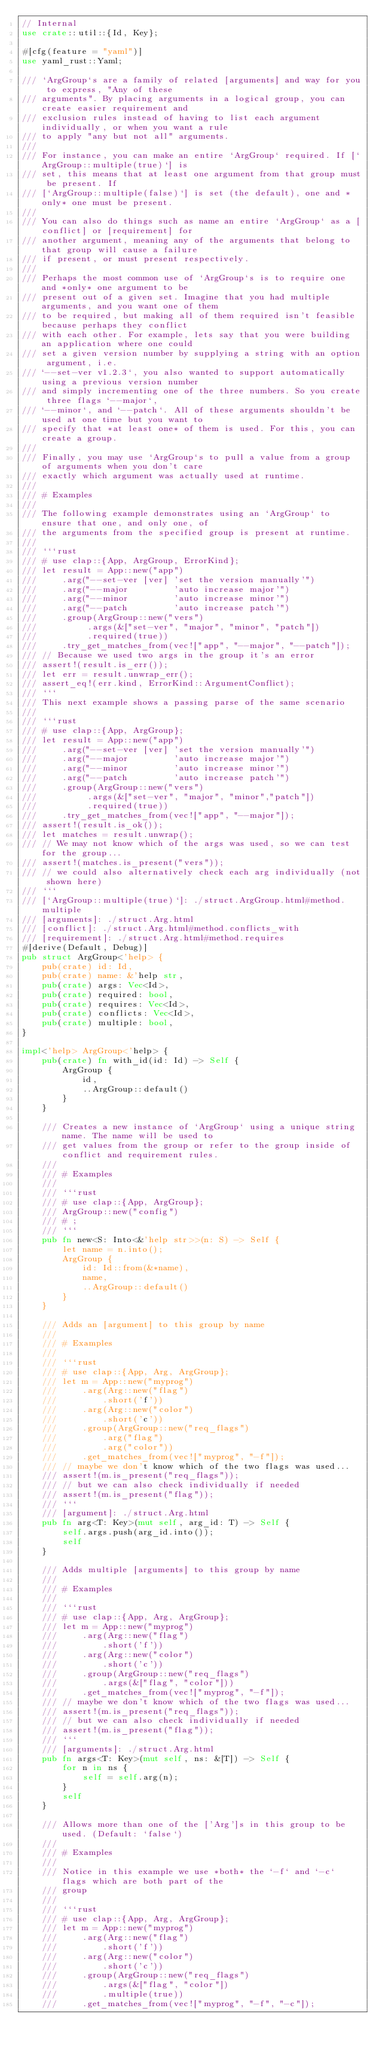Convert code to text. <code><loc_0><loc_0><loc_500><loc_500><_Rust_>// Internal
use crate::util::{Id, Key};

#[cfg(feature = "yaml")]
use yaml_rust::Yaml;

/// `ArgGroup`s are a family of related [arguments] and way for you to express, "Any of these
/// arguments". By placing arguments in a logical group, you can create easier requirement and
/// exclusion rules instead of having to list each argument individually, or when you want a rule
/// to apply "any but not all" arguments.
///
/// For instance, you can make an entire `ArgGroup` required. If [`ArgGroup::multiple(true)`] is
/// set, this means that at least one argument from that group must be present. If
/// [`ArgGroup::multiple(false)`] is set (the default), one and *only* one must be present.
///
/// You can also do things such as name an entire `ArgGroup` as a [conflict] or [requirement] for
/// another argument, meaning any of the arguments that belong to that group will cause a failure
/// if present, or must present respectively.
///
/// Perhaps the most common use of `ArgGroup`s is to require one and *only* one argument to be
/// present out of a given set. Imagine that you had multiple arguments, and you want one of them
/// to be required, but making all of them required isn't feasible because perhaps they conflict
/// with each other. For example, lets say that you were building an application where one could
/// set a given version number by supplying a string with an option argument, i.e.
/// `--set-ver v1.2.3`, you also wanted to support automatically using a previous version number
/// and simply incrementing one of the three numbers. So you create three flags `--major`,
/// `--minor`, and `--patch`. All of these arguments shouldn't be used at one time but you want to
/// specify that *at least one* of them is used. For this, you can create a group.
///
/// Finally, you may use `ArgGroup`s to pull a value from a group of arguments when you don't care
/// exactly which argument was actually used at runtime.
///
/// # Examples
///
/// The following example demonstrates using an `ArgGroup` to ensure that one, and only one, of
/// the arguments from the specified group is present at runtime.
///
/// ```rust
/// # use clap::{App, ArgGroup, ErrorKind};
/// let result = App::new("app")
///     .arg("--set-ver [ver] 'set the version manually'")
///     .arg("--major         'auto increase major'")
///     .arg("--minor         'auto increase minor'")
///     .arg("--patch         'auto increase patch'")
///     .group(ArgGroup::new("vers")
///          .args(&["set-ver", "major", "minor", "patch"])
///          .required(true))
///     .try_get_matches_from(vec!["app", "--major", "--patch"]);
/// // Because we used two args in the group it's an error
/// assert!(result.is_err());
/// let err = result.unwrap_err();
/// assert_eq!(err.kind, ErrorKind::ArgumentConflict);
/// ```
/// This next example shows a passing parse of the same scenario
///
/// ```rust
/// # use clap::{App, ArgGroup};
/// let result = App::new("app")
///     .arg("--set-ver [ver] 'set the version manually'")
///     .arg("--major         'auto increase major'")
///     .arg("--minor         'auto increase minor'")
///     .arg("--patch         'auto increase patch'")
///     .group(ArgGroup::new("vers")
///          .args(&["set-ver", "major", "minor","patch"])
///          .required(true))
///     .try_get_matches_from(vec!["app", "--major"]);
/// assert!(result.is_ok());
/// let matches = result.unwrap();
/// // We may not know which of the args was used, so we can test for the group...
/// assert!(matches.is_present("vers"));
/// // we could also alternatively check each arg individually (not shown here)
/// ```
/// [`ArgGroup::multiple(true)`]: ./struct.ArgGroup.html#method.multiple
/// [arguments]: ./struct.Arg.html
/// [conflict]: ./struct.Arg.html#method.conflicts_with
/// [requirement]: ./struct.Arg.html#method.requires
#[derive(Default, Debug)]
pub struct ArgGroup<'help> {
    pub(crate) id: Id,
    pub(crate) name: &'help str,
    pub(crate) args: Vec<Id>,
    pub(crate) required: bool,
    pub(crate) requires: Vec<Id>,
    pub(crate) conflicts: Vec<Id>,
    pub(crate) multiple: bool,
}

impl<'help> ArgGroup<'help> {
    pub(crate) fn with_id(id: Id) -> Self {
        ArgGroup {
            id,
            ..ArgGroup::default()
        }
    }

    /// Creates a new instance of `ArgGroup` using a unique string name. The name will be used to
    /// get values from the group or refer to the group inside of conflict and requirement rules.
    ///
    /// # Examples
    ///
    /// ```rust
    /// # use clap::{App, ArgGroup};
    /// ArgGroup::new("config")
    /// # ;
    /// ```
    pub fn new<S: Into<&'help str>>(n: S) -> Self {
        let name = n.into();
        ArgGroup {
            id: Id::from(&*name),
            name,
            ..ArgGroup::default()
        }
    }

    /// Adds an [argument] to this group by name
    ///
    /// # Examples
    ///
    /// ```rust
    /// # use clap::{App, Arg, ArgGroup};
    /// let m = App::new("myprog")
    ///     .arg(Arg::new("flag")
    ///         .short('f'))
    ///     .arg(Arg::new("color")
    ///         .short('c'))
    ///     .group(ArgGroup::new("req_flags")
    ///         .arg("flag")
    ///         .arg("color"))
    ///     .get_matches_from(vec!["myprog", "-f"]);
    /// // maybe we don't know which of the two flags was used...
    /// assert!(m.is_present("req_flags"));
    /// // but we can also check individually if needed
    /// assert!(m.is_present("flag"));
    /// ```
    /// [argument]: ./struct.Arg.html
    pub fn arg<T: Key>(mut self, arg_id: T) -> Self {
        self.args.push(arg_id.into());
        self
    }

    /// Adds multiple [arguments] to this group by name
    ///
    /// # Examples
    ///
    /// ```rust
    /// # use clap::{App, Arg, ArgGroup};
    /// let m = App::new("myprog")
    ///     .arg(Arg::new("flag")
    ///         .short('f'))
    ///     .arg(Arg::new("color")
    ///         .short('c'))
    ///     .group(ArgGroup::new("req_flags")
    ///         .args(&["flag", "color"]))
    ///     .get_matches_from(vec!["myprog", "-f"]);
    /// // maybe we don't know which of the two flags was used...
    /// assert!(m.is_present("req_flags"));
    /// // but we can also check individually if needed
    /// assert!(m.is_present("flag"));
    /// ```
    /// [arguments]: ./struct.Arg.html
    pub fn args<T: Key>(mut self, ns: &[T]) -> Self {
        for n in ns {
            self = self.arg(n);
        }
        self
    }

    /// Allows more than one of the ['Arg']s in this group to be used. (Default: `false`)
    ///
    /// # Examples
    ///
    /// Notice in this example we use *both* the `-f` and `-c` flags which are both part of the
    /// group
    ///
    /// ```rust
    /// # use clap::{App, Arg, ArgGroup};
    /// let m = App::new("myprog")
    ///     .arg(Arg::new("flag")
    ///         .short('f'))
    ///     .arg(Arg::new("color")
    ///         .short('c'))
    ///     .group(ArgGroup::new("req_flags")
    ///         .args(&["flag", "color"])
    ///         .multiple(true))
    ///     .get_matches_from(vec!["myprog", "-f", "-c"]);</code> 